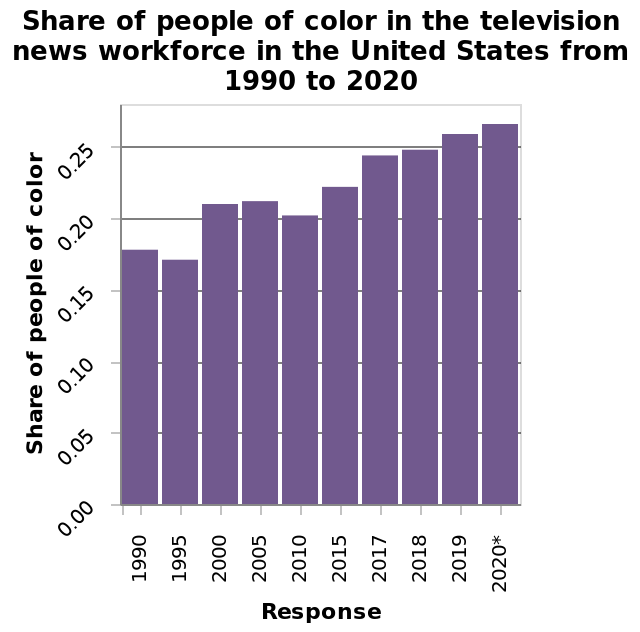<image>
What is the range of years covered by the x-axis? The x-axis spans from 1990 to 2020. What type of scale is used for the x-axis? The x-axis is measured using a categorical scale. 